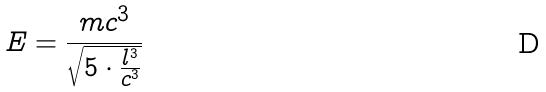<formula> <loc_0><loc_0><loc_500><loc_500>E = \frac { m c ^ { 3 } } { \sqrt { 5 \cdot \frac { l ^ { 3 } } { c ^ { 3 } } } }</formula> 